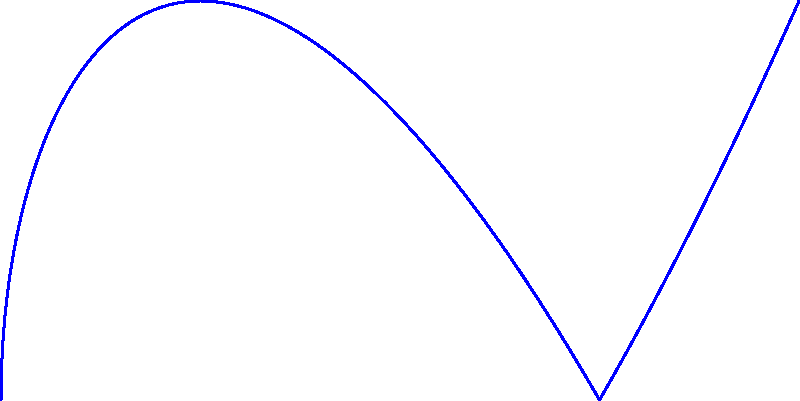Consider the elliptic curve $E: y^2 = x^3 - 3x + 2$ over a finite field. The diagram shows points $P$, $2P$, and $3P$ on this curve. If point $P$ represents a public key in an elliptic curve cryptosystem, what geometric transformation best describes the process of computing $3P$ from $P$? To understand the geometric transformation from $P$ to $3P$, we need to follow these steps:

1) In elliptic curve cryptography, scalar multiplication (e.g., $3P$) is achieved through repeated point addition.

2) To get from $P$ to $3P$, we first compute $2P$ and then add $P$ to $2P$:

   $3P = P + 2P$

3) The computation of $2P$ from $P$ involves:
   a) Drawing a tangent line to the curve at point $P$
   b) Finding where this line intersects the curve at another point
   c) Reflecting this intersection point across the x-axis

4) The computation of $3P$ from $2P$ and $P$ involves:
   a) Drawing a line through points $2P$ and $P$
   b) Finding where this line intersects the curve at a third point
   c) Reflecting this intersection point across the x-axis

5) These operations can be described as a sequence of:
   - Line drawing (tangent or secant)
   - Point intersection
   - Reflection

6) The overall transformation from $P$ to $3P$ is therefore a composition of these geometric operations, primarily involving line intersections and reflections.

Therefore, the best description of the geometric transformation from $P$ to $3P$ is a sequence of line intersections and reflections.
Answer: Sequence of line intersections and reflections 